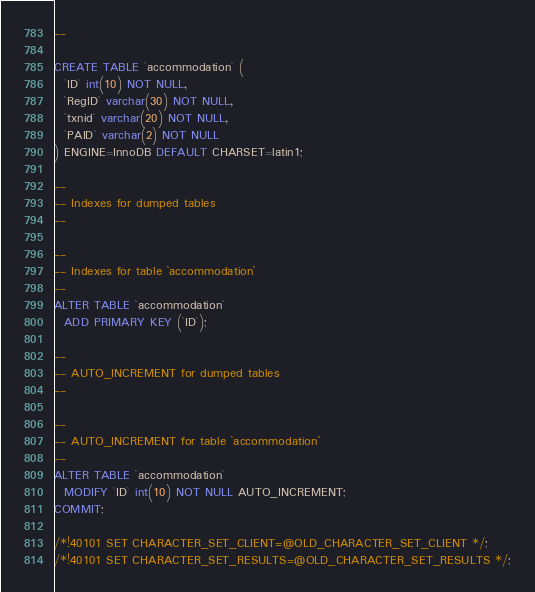Convert code to text. <code><loc_0><loc_0><loc_500><loc_500><_SQL_>--

CREATE TABLE `accommodation` (
  `ID` int(10) NOT NULL,
  `RegID` varchar(30) NOT NULL,
  `txnid` varchar(20) NOT NULL,
  `PAID` varchar(2) NOT NULL
) ENGINE=InnoDB DEFAULT CHARSET=latin1;

--
-- Indexes for dumped tables
--

--
-- Indexes for table `accommodation`
--
ALTER TABLE `accommodation`
  ADD PRIMARY KEY (`ID`);

--
-- AUTO_INCREMENT for dumped tables
--

--
-- AUTO_INCREMENT for table `accommodation`
--
ALTER TABLE `accommodation`
  MODIFY `ID` int(10) NOT NULL AUTO_INCREMENT;
COMMIT;

/*!40101 SET CHARACTER_SET_CLIENT=@OLD_CHARACTER_SET_CLIENT */;
/*!40101 SET CHARACTER_SET_RESULTS=@OLD_CHARACTER_SET_RESULTS */;</code> 